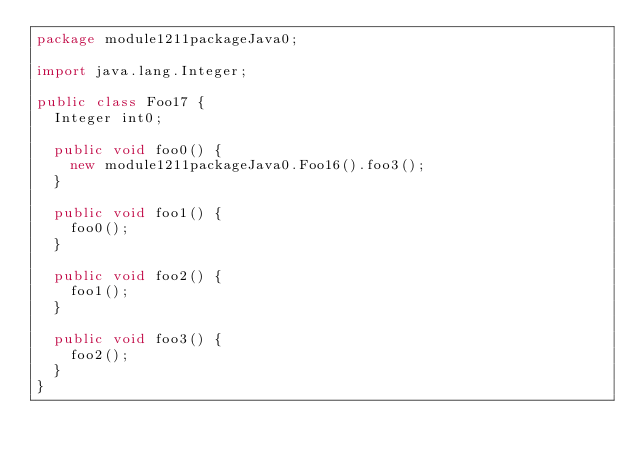Convert code to text. <code><loc_0><loc_0><loc_500><loc_500><_Java_>package module1211packageJava0;

import java.lang.Integer;

public class Foo17 {
  Integer int0;

  public void foo0() {
    new module1211packageJava0.Foo16().foo3();
  }

  public void foo1() {
    foo0();
  }

  public void foo2() {
    foo1();
  }

  public void foo3() {
    foo2();
  }
}
</code> 